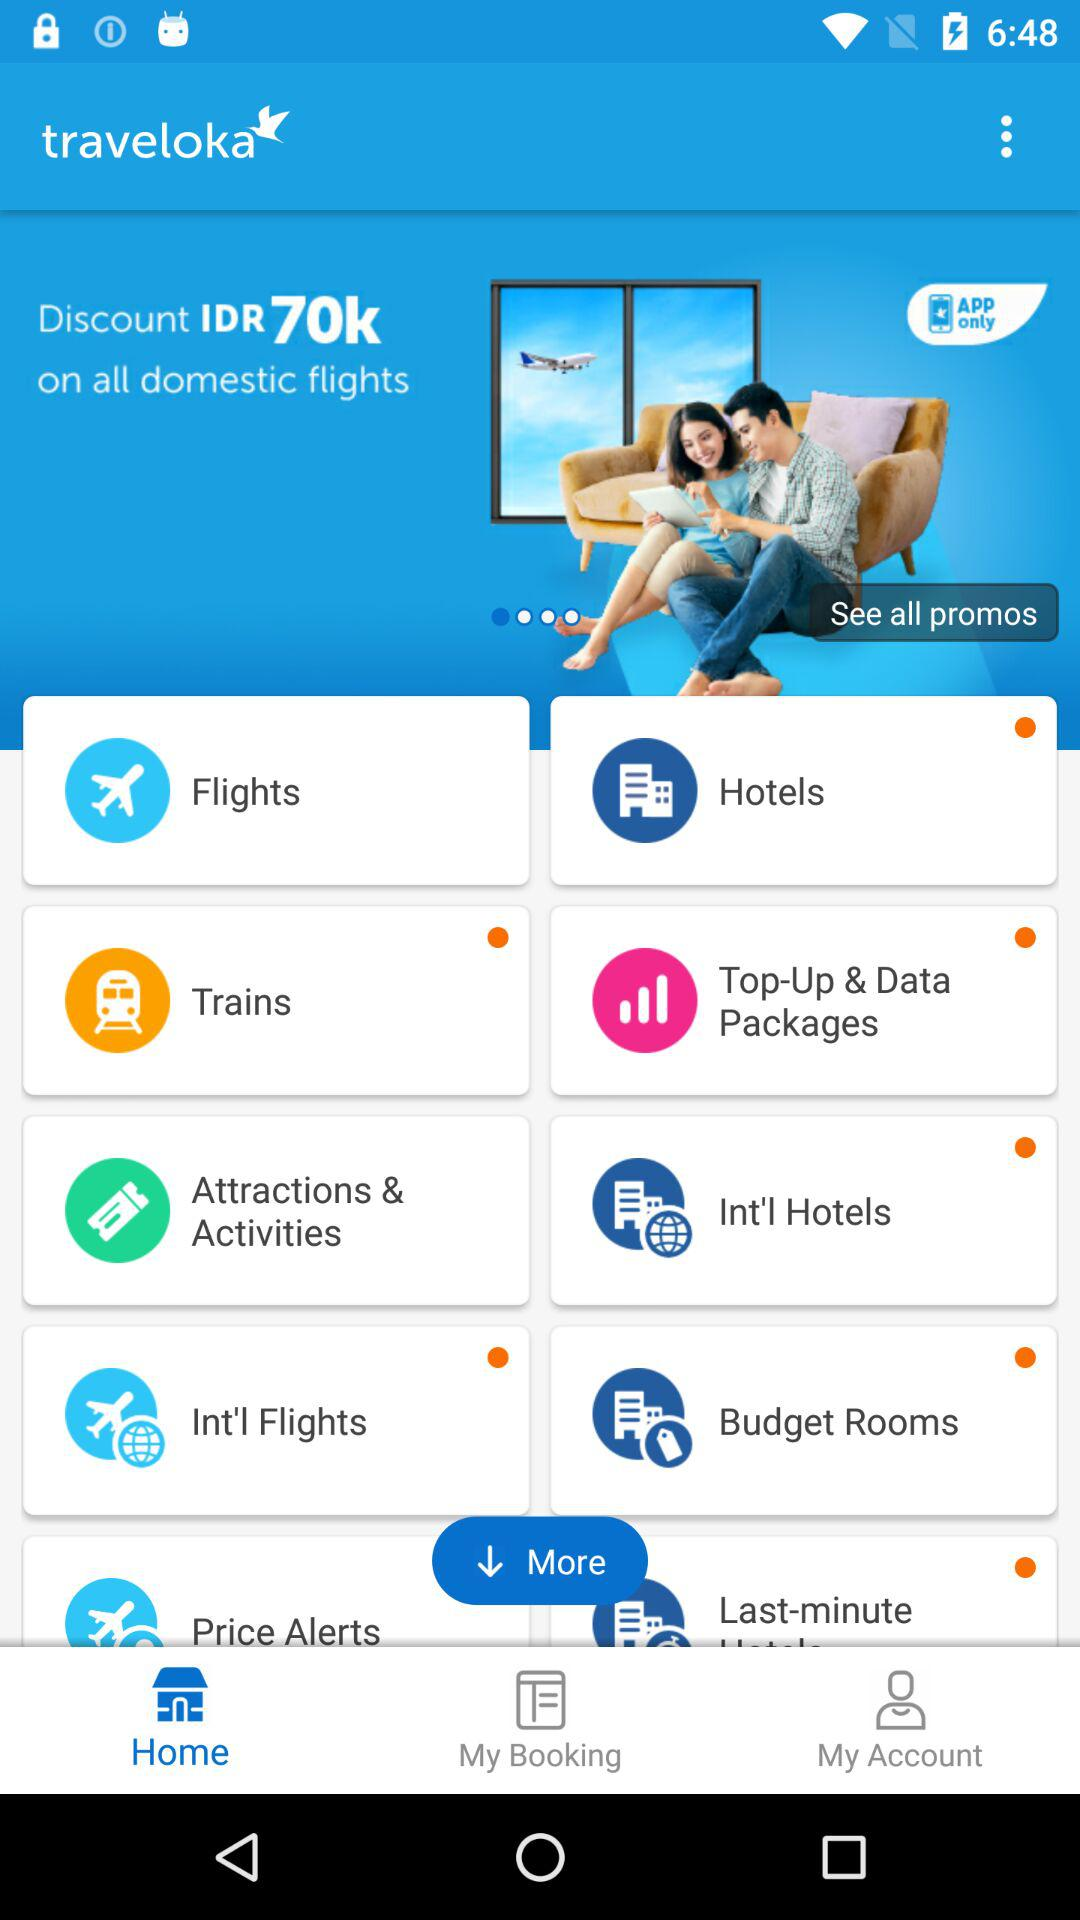How much of a discount is there on all domestic flights? The discount on all domestic flights is IDR70k. 